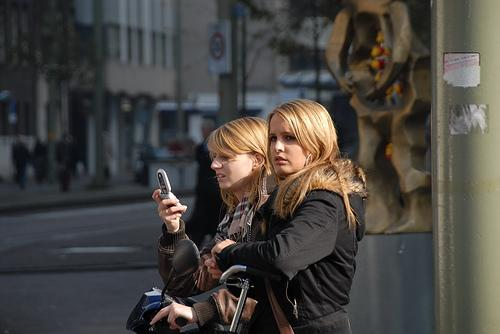The woman on the phone is using what item to move around? Please explain your reasoning. scooter. There is a pole under one of the women. 